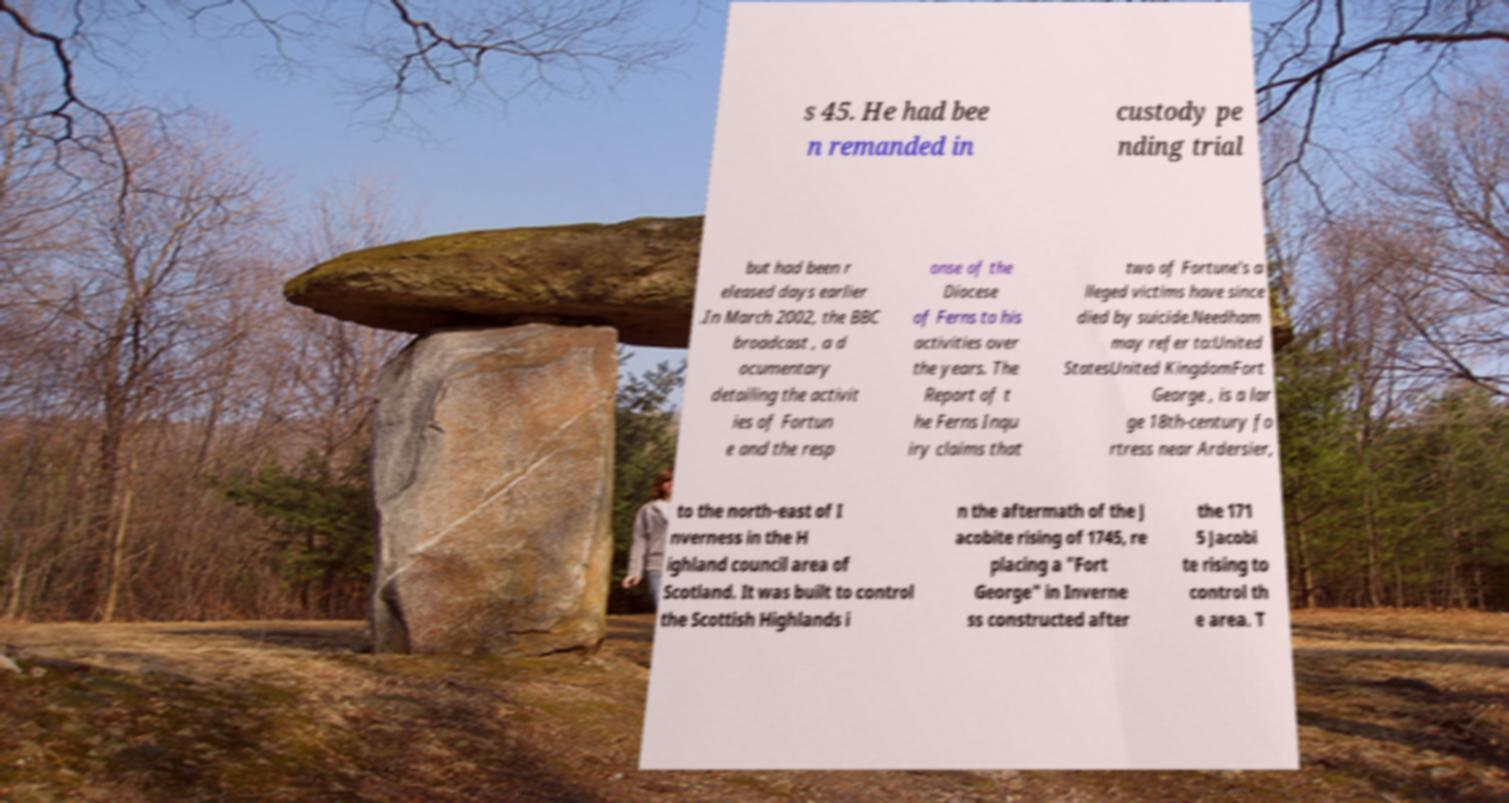Could you extract and type out the text from this image? s 45. He had bee n remanded in custody pe nding trial but had been r eleased days earlier .In March 2002, the BBC broadcast , a d ocumentary detailing the activit ies of Fortun e and the resp onse of the Diocese of Ferns to his activities over the years. The Report of t he Ferns Inqu iry claims that two of Fortune's a lleged victims have since died by suicide.Needham may refer to:United StatesUnited KingdomFort George , is a lar ge 18th-century fo rtress near Ardersier, to the north-east of I nverness in the H ighland council area of Scotland. It was built to control the Scottish Highlands i n the aftermath of the J acobite rising of 1745, re placing a "Fort George" in Inverne ss constructed after the 171 5 Jacobi te rising to control th e area. T 